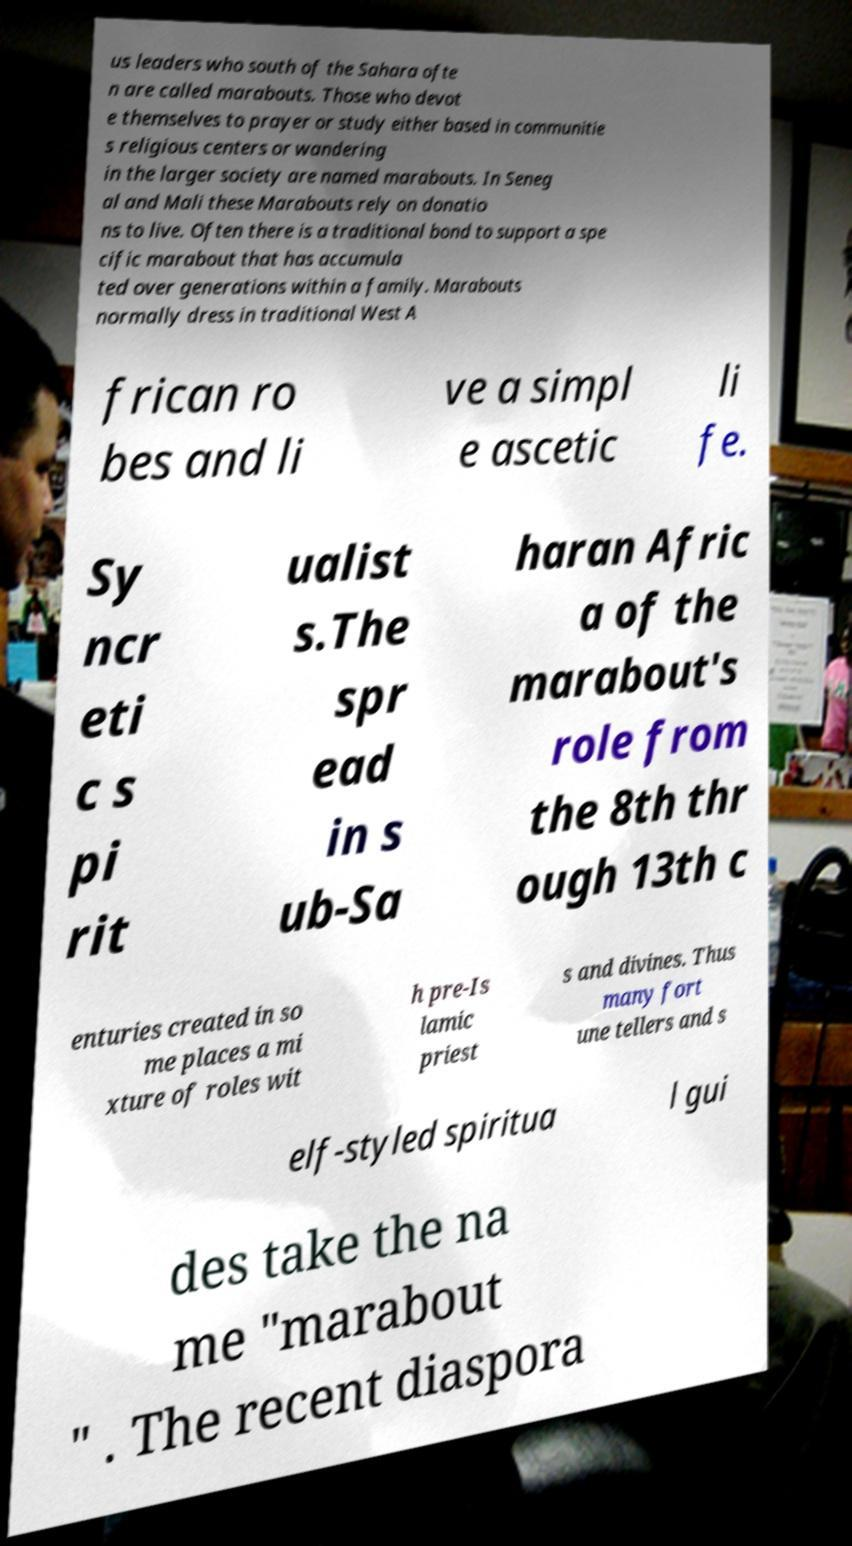Please read and relay the text visible in this image. What does it say? us leaders who south of the Sahara ofte n are called marabouts. Those who devot e themselves to prayer or study either based in communitie s religious centers or wandering in the larger society are named marabouts. In Seneg al and Mali these Marabouts rely on donatio ns to live. Often there is a traditional bond to support a spe cific marabout that has accumula ted over generations within a family. Marabouts normally dress in traditional West A frican ro bes and li ve a simpl e ascetic li fe. Sy ncr eti c s pi rit ualist s.The spr ead in s ub-Sa haran Afric a of the marabout's role from the 8th thr ough 13th c enturies created in so me places a mi xture of roles wit h pre-Is lamic priest s and divines. Thus many fort une tellers and s elf-styled spiritua l gui des take the na me "marabout " . The recent diaspora 